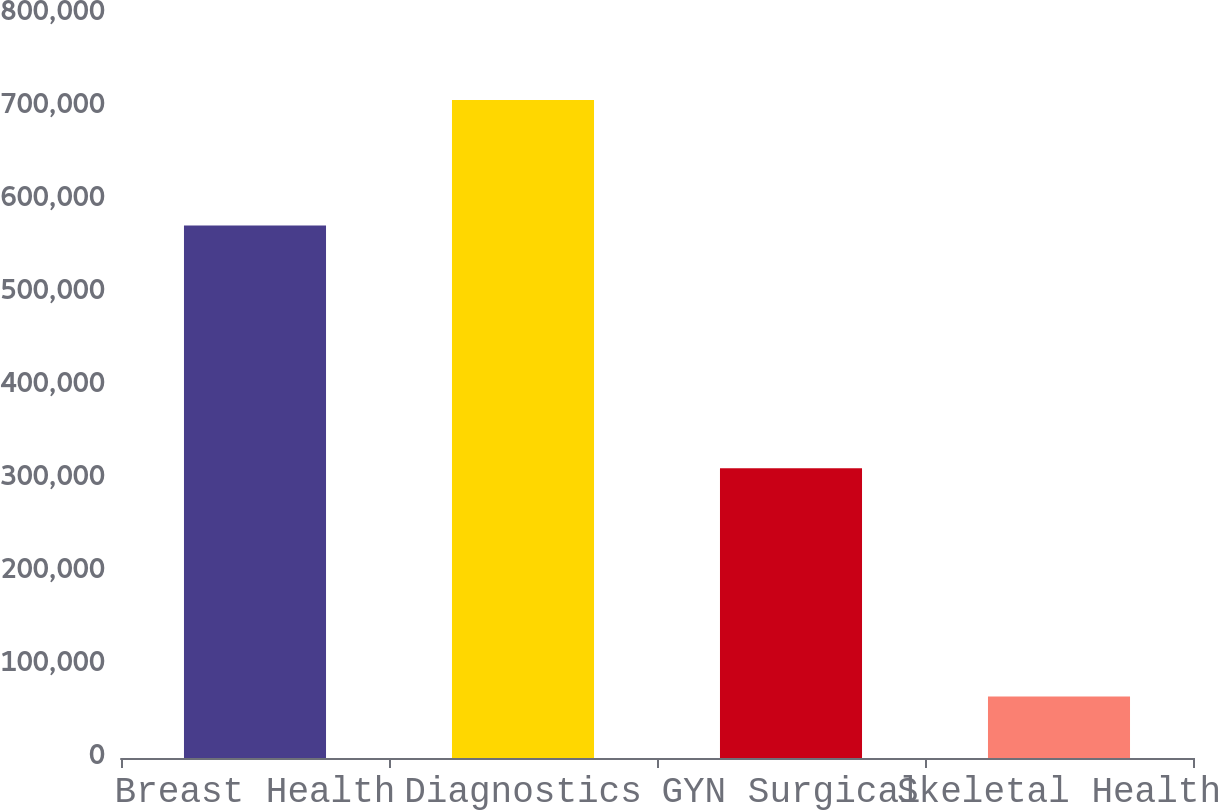<chart> <loc_0><loc_0><loc_500><loc_500><bar_chart><fcel>Breast Health<fcel>Diagnostics<fcel>GYN Surgical<fcel>Skeletal Health<nl><fcel>572485<fcel>707529<fcel>311643<fcel>66071<nl></chart> 